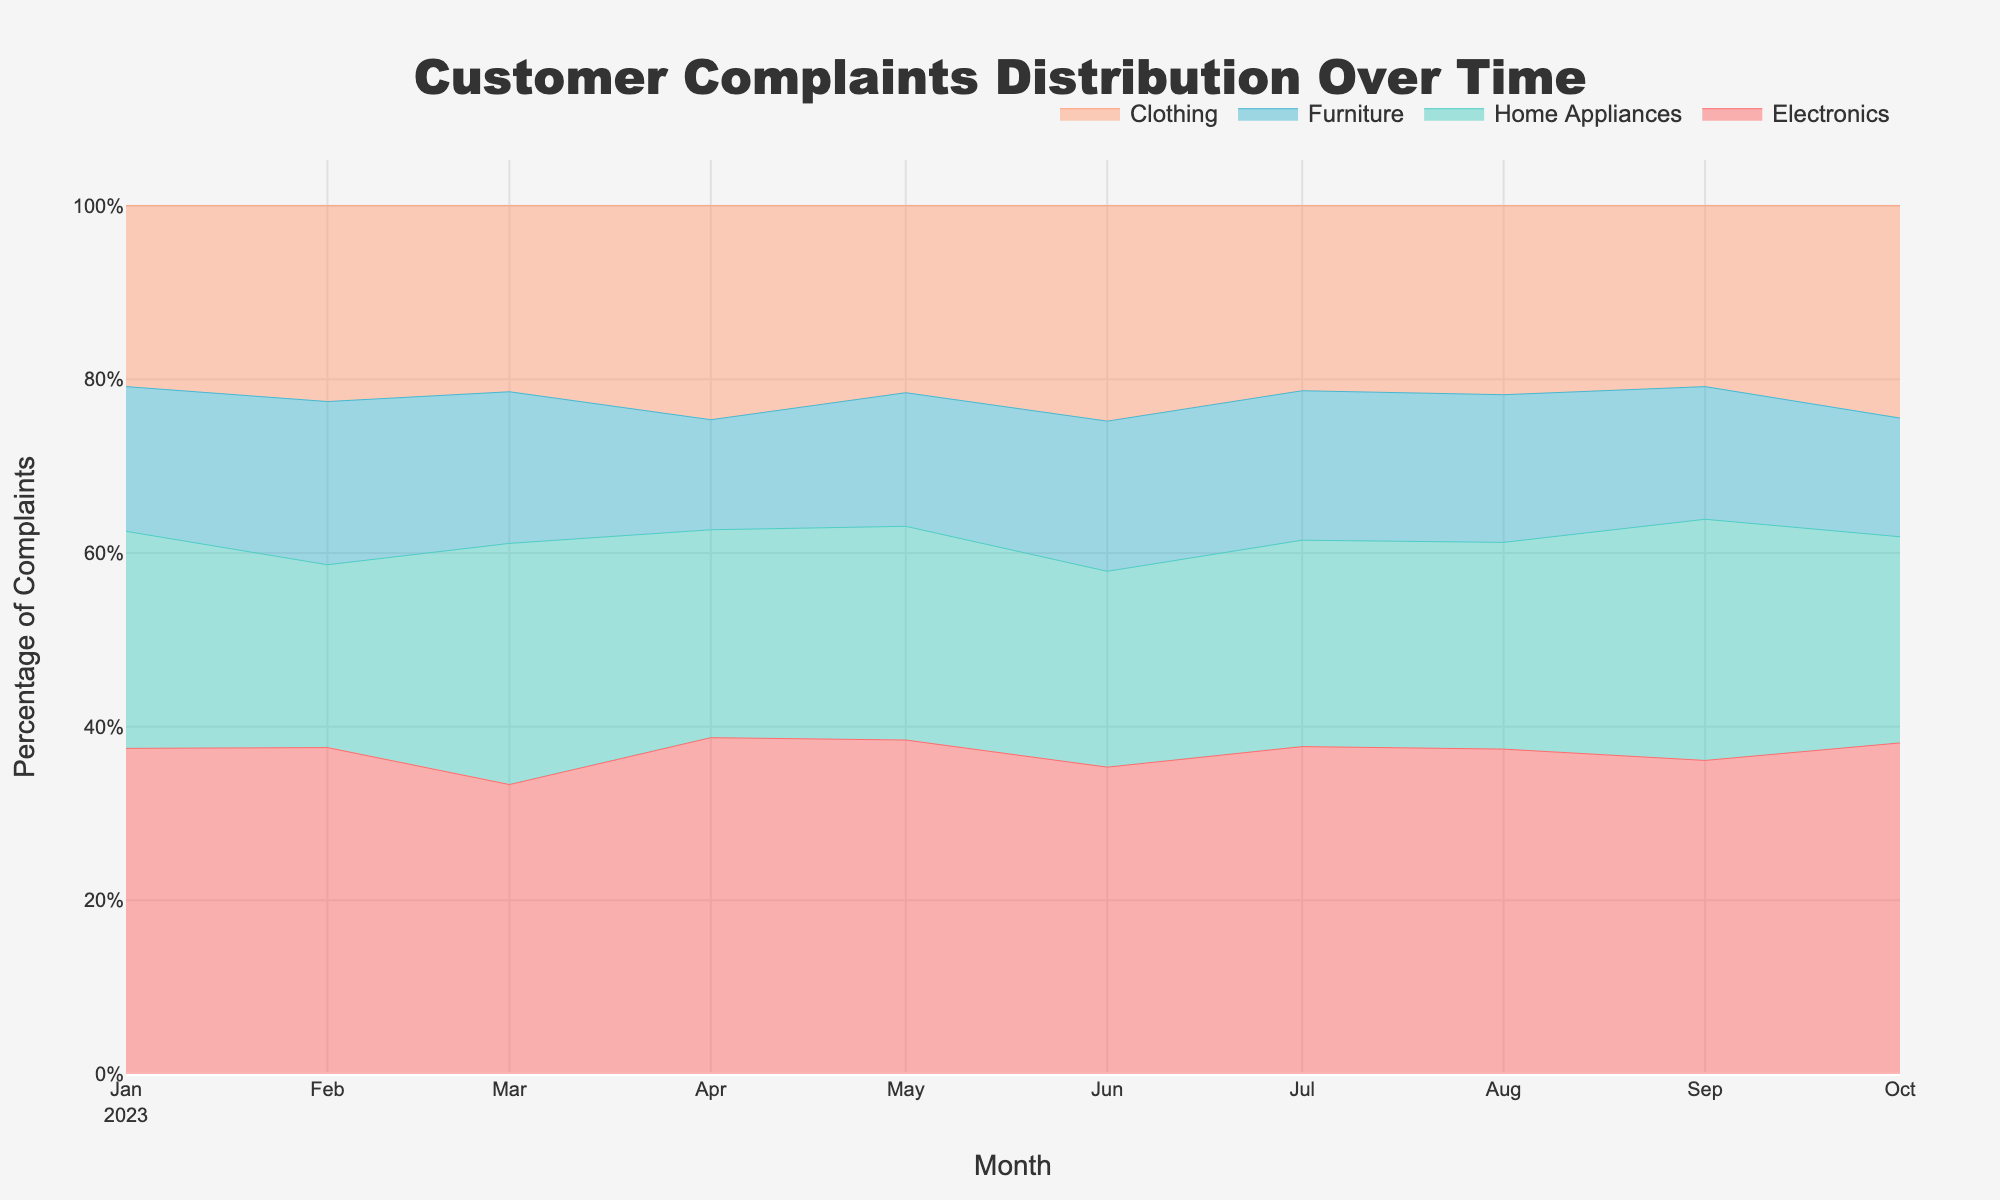What is the title of the graph? The title of the graph can be found at the top of the plot. It usually provides a summary of the data being visualized.
Answer: Customer Complaints Distribution Over Time What does the x-axis represent? By looking at the labels along the horizontal line (x-axis) of the graph, we can determine what it represents.
Answer: Month Which product category had the highest percentage of complaints in August 2023? To find this, look at the data for August 2023 along the x-axis and identify which line segment takes up the largest area for that month.
Answer: Electronics Between which months did the number of complaints for Electronics see a noticeable increase? Look at the trendline for the 'Electronics' category and identify the periods where there is a significant upward slope.
Answer: Between March and April 2023 How did the percentage of complaints for Home Appliances change from January to April 2023? Locate the 'Home Appliances' category and compare the areas in January and April 2023. Calculate the difference in size.
Answer: Increased Which product category had the least variation in complaints over the time period? Look for the stream (line segment) that exhibits the least fluctuation in size across the months.
Answer: Furniture How do the total complaints in January 2023 compare to those in October 2023? Sum the complaints for all product categories in January 2023 and October 2023, and then compare the totals.
Answer: 120 in January, 139 in October What is the difference in the percentage of complaints between Electronics and Clothing in May 2023? Examine the graph for May 2023, and identify the sizes of the streams for Electronics and Clothing. Subtract the percentage of Clothing from that of Electronics.
Answer: Electronics leads by approximately 22% In which month did Clothing experience the largest increase in complaints? Track the trends for Clothing month by month and identify where the biggest jump occurs.
Answer: April 2023 Which product category consistently remained above 20% of the complaints throughout the entire period? Observe the graph and detect if any category (stream) never drops below the 20% mark across all months.
Answer: Electronics 